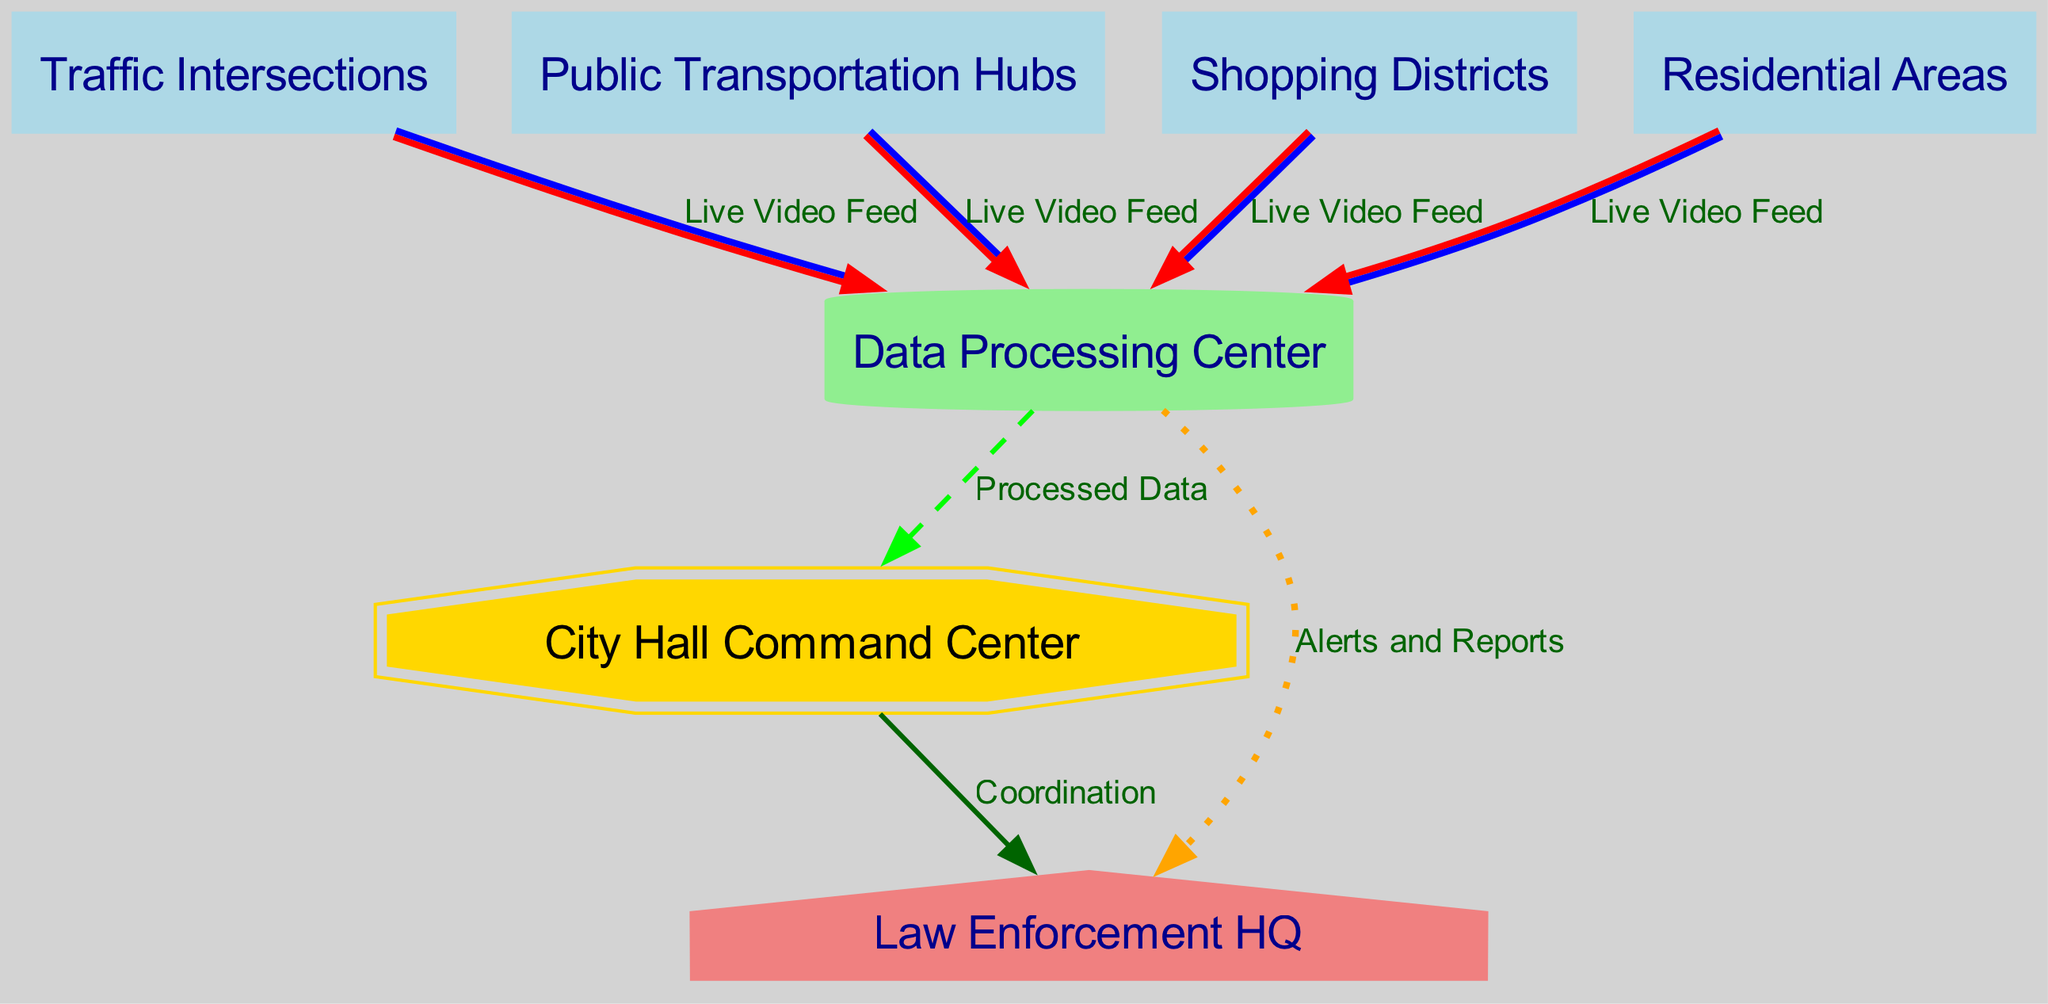What is the total number of nodes in the diagram? The diagram includes nodes representing various locations and centers. Counting each node listed (City Hall Command Center, Traffic Intersections, Public Transportation Hubs, Shopping Districts, Residential Areas, Data Processing Center, and Law Enforcement HQ), we find there are seven nodes overall.
Answer: Seven Which node is responsible for processing and distributing data? The Data Processing Center is identified as the node that processes data, indicated by its unique label and cylinder shape. It receives live video feeds from various other nodes.
Answer: Data Processing Center How many locations provide a live video feed to the Data Processing Center? By examining the connections leading to the Data Processing Center, we note it receives live video feeds from four distinct locations: Traffic Intersections, Public Transportation Hubs, Shopping Districts, and Residential Areas.
Answer: Four What type of connection exists between the City Hall Command Center and Law Enforcement HQ? The diagram indicates a connection labeled “Coordination,” which suggests a direct relationship focused on operational collaboration or communication between these two entities.
Answer: Coordination What type of connection do Traffic Intersections have to the Data Processing Center? The connection from Traffic Intersections to the Data Processing Center is labeled “Live Video Feed,” denoting that this location feeds real-time video to the processing center.
Answer: Live Video Feed Which node has the highest hierarchical prominence in the diagram based on its shape? The City Hall Command Center, depicted as a double octagon and colored gold, indicates its significance and higher hierarchical status among the other nodes.
Answer: City Hall Command Center What information does the Data Processing Center relay to the Law Enforcement HQ? The Data Processing Center sends “Alerts and Reports” to the Law Enforcement HQ, which suggests that processed data may lead to actionable intelligence for law enforcement operations.
Answer: Alerts and Reports How many edges are present leading out of the Data Processing Center? Analyzing the connections from the Data Processing Center, we see it has two edges extending outward: one to the City Hall Command Center and another to the Law Enforcement HQ, totaling two connections.
Answer: Two 